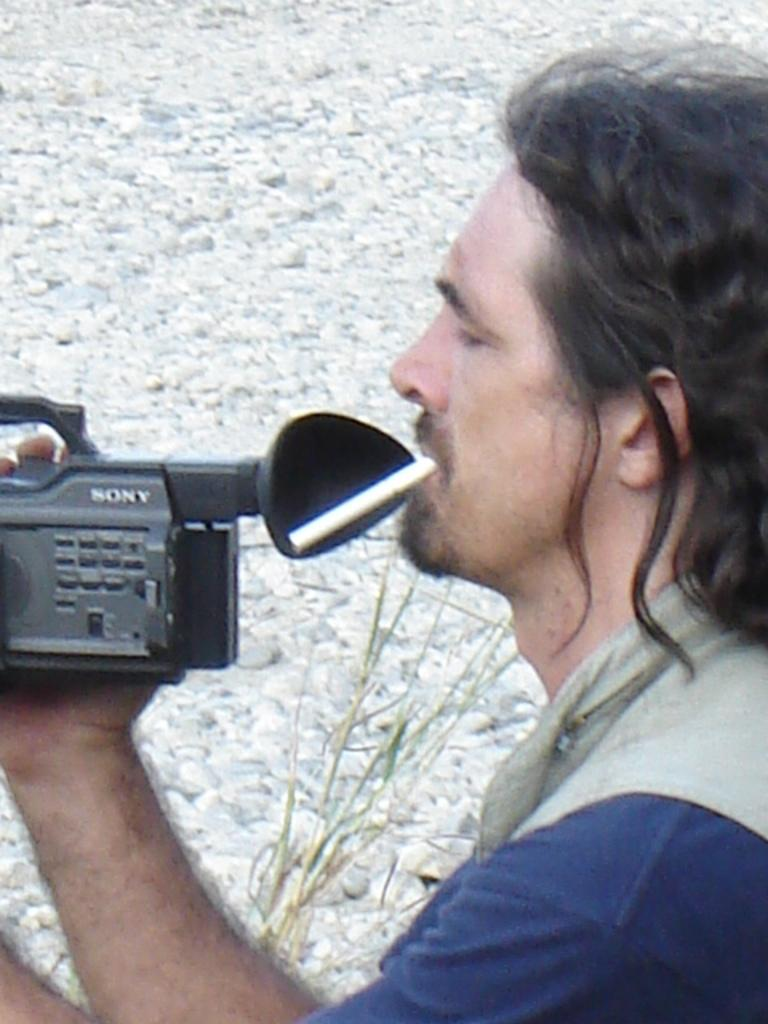What is the person in the image holding? The person is holding a camera. What activity is the person engaged in? The person is smoking a cigarette. What can be seen in the background of the image? There are white color stones and a plant in the background. What type of vein is visible in the image? There is no vein visible in the image. What flavor of cigarette is the person smoking in the image? The flavor of the cigarette cannot be determined from the image. 